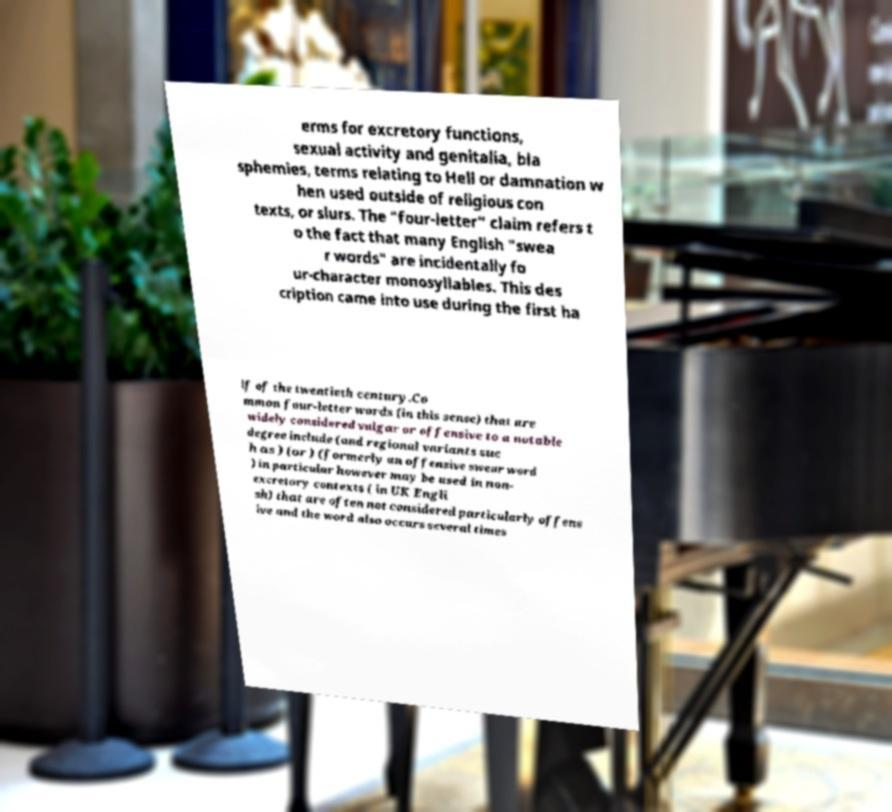There's text embedded in this image that I need extracted. Can you transcribe it verbatim? erms for excretory functions, sexual activity and genitalia, bla sphemies, terms relating to Hell or damnation w hen used outside of religious con texts, or slurs. The "four-letter" claim refers t o the fact that many English "swea r words" are incidentally fo ur-character monosyllables. This des cription came into use during the first ha lf of the twentieth century.Co mmon four-letter words (in this sense) that are widely considered vulgar or offensive to a notable degree include (and regional variants suc h as ) (or ) (formerly an offensive swear word ) in particular however may be used in non- excretory contexts ( in UK Engli sh) that are often not considered particularly offens ive and the word also occurs several times 